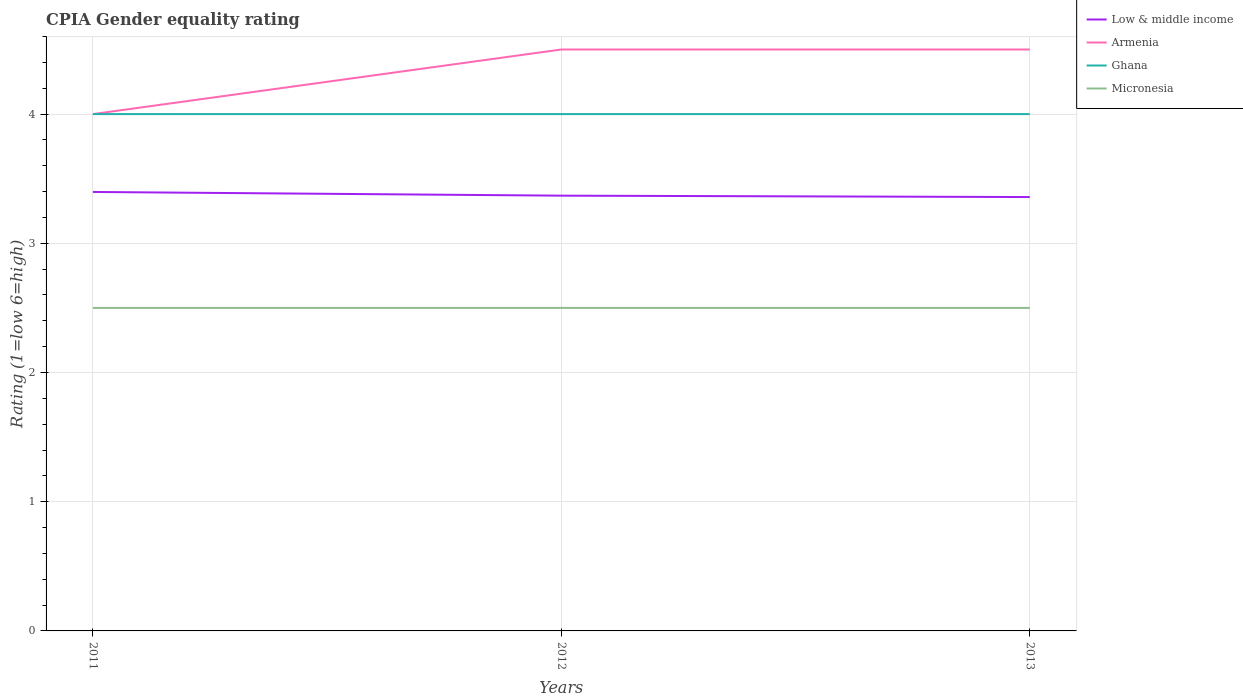How many different coloured lines are there?
Provide a short and direct response. 4. Is the number of lines equal to the number of legend labels?
Your answer should be very brief. Yes. Across all years, what is the maximum CPIA rating in Ghana?
Give a very brief answer. 4. In which year was the CPIA rating in Armenia maximum?
Your answer should be very brief. 2011. Is the CPIA rating in Micronesia strictly greater than the CPIA rating in Armenia over the years?
Provide a succinct answer. Yes. How many lines are there?
Ensure brevity in your answer.  4. How many years are there in the graph?
Provide a short and direct response. 3. Does the graph contain any zero values?
Your answer should be compact. No. Where does the legend appear in the graph?
Offer a terse response. Top right. How are the legend labels stacked?
Your answer should be very brief. Vertical. What is the title of the graph?
Keep it short and to the point. CPIA Gender equality rating. What is the Rating (1=low 6=high) of Low & middle income in 2011?
Provide a short and direct response. 3.4. What is the Rating (1=low 6=high) in Armenia in 2011?
Give a very brief answer. 4. What is the Rating (1=low 6=high) in Ghana in 2011?
Offer a terse response. 4. What is the Rating (1=low 6=high) in Low & middle income in 2012?
Offer a terse response. 3.37. What is the Rating (1=low 6=high) of Armenia in 2012?
Keep it short and to the point. 4.5. What is the Rating (1=low 6=high) of Low & middle income in 2013?
Keep it short and to the point. 3.36. What is the Rating (1=low 6=high) in Armenia in 2013?
Give a very brief answer. 4.5. What is the Rating (1=low 6=high) of Ghana in 2013?
Provide a succinct answer. 4. What is the Rating (1=low 6=high) of Micronesia in 2013?
Make the answer very short. 2.5. Across all years, what is the maximum Rating (1=low 6=high) of Low & middle income?
Make the answer very short. 3.4. Across all years, what is the minimum Rating (1=low 6=high) in Low & middle income?
Give a very brief answer. 3.36. Across all years, what is the minimum Rating (1=low 6=high) in Ghana?
Make the answer very short. 4. Across all years, what is the minimum Rating (1=low 6=high) of Micronesia?
Offer a terse response. 2.5. What is the total Rating (1=low 6=high) of Low & middle income in the graph?
Keep it short and to the point. 10.12. What is the total Rating (1=low 6=high) in Armenia in the graph?
Provide a succinct answer. 13. What is the difference between the Rating (1=low 6=high) of Low & middle income in 2011 and that in 2012?
Offer a very short reply. 0.03. What is the difference between the Rating (1=low 6=high) in Micronesia in 2011 and that in 2012?
Your answer should be compact. 0. What is the difference between the Rating (1=low 6=high) of Low & middle income in 2011 and that in 2013?
Your answer should be compact. 0.04. What is the difference between the Rating (1=low 6=high) of Ghana in 2011 and that in 2013?
Your answer should be compact. 0. What is the difference between the Rating (1=low 6=high) in Low & middle income in 2012 and that in 2013?
Offer a very short reply. 0.01. What is the difference between the Rating (1=low 6=high) of Armenia in 2012 and that in 2013?
Your answer should be very brief. 0. What is the difference between the Rating (1=low 6=high) of Ghana in 2012 and that in 2013?
Keep it short and to the point. 0. What is the difference between the Rating (1=low 6=high) of Low & middle income in 2011 and the Rating (1=low 6=high) of Armenia in 2012?
Give a very brief answer. -1.1. What is the difference between the Rating (1=low 6=high) in Low & middle income in 2011 and the Rating (1=low 6=high) in Ghana in 2012?
Ensure brevity in your answer.  -0.6. What is the difference between the Rating (1=low 6=high) of Low & middle income in 2011 and the Rating (1=low 6=high) of Micronesia in 2012?
Your answer should be very brief. 0.9. What is the difference between the Rating (1=low 6=high) in Armenia in 2011 and the Rating (1=low 6=high) in Ghana in 2012?
Provide a succinct answer. 0. What is the difference between the Rating (1=low 6=high) in Armenia in 2011 and the Rating (1=low 6=high) in Micronesia in 2012?
Ensure brevity in your answer.  1.5. What is the difference between the Rating (1=low 6=high) of Ghana in 2011 and the Rating (1=low 6=high) of Micronesia in 2012?
Keep it short and to the point. 1.5. What is the difference between the Rating (1=low 6=high) in Low & middle income in 2011 and the Rating (1=low 6=high) in Armenia in 2013?
Give a very brief answer. -1.1. What is the difference between the Rating (1=low 6=high) of Low & middle income in 2011 and the Rating (1=low 6=high) of Ghana in 2013?
Provide a short and direct response. -0.6. What is the difference between the Rating (1=low 6=high) in Low & middle income in 2011 and the Rating (1=low 6=high) in Micronesia in 2013?
Offer a very short reply. 0.9. What is the difference between the Rating (1=low 6=high) in Ghana in 2011 and the Rating (1=low 6=high) in Micronesia in 2013?
Ensure brevity in your answer.  1.5. What is the difference between the Rating (1=low 6=high) in Low & middle income in 2012 and the Rating (1=low 6=high) in Armenia in 2013?
Your answer should be very brief. -1.13. What is the difference between the Rating (1=low 6=high) in Low & middle income in 2012 and the Rating (1=low 6=high) in Ghana in 2013?
Provide a succinct answer. -0.63. What is the difference between the Rating (1=low 6=high) of Low & middle income in 2012 and the Rating (1=low 6=high) of Micronesia in 2013?
Give a very brief answer. 0.87. What is the difference between the Rating (1=low 6=high) in Armenia in 2012 and the Rating (1=low 6=high) in Micronesia in 2013?
Ensure brevity in your answer.  2. What is the average Rating (1=low 6=high) in Low & middle income per year?
Keep it short and to the point. 3.37. What is the average Rating (1=low 6=high) of Armenia per year?
Your answer should be very brief. 4.33. What is the average Rating (1=low 6=high) in Micronesia per year?
Ensure brevity in your answer.  2.5. In the year 2011, what is the difference between the Rating (1=low 6=high) in Low & middle income and Rating (1=low 6=high) in Armenia?
Offer a very short reply. -0.6. In the year 2011, what is the difference between the Rating (1=low 6=high) in Low & middle income and Rating (1=low 6=high) in Ghana?
Your answer should be compact. -0.6. In the year 2011, what is the difference between the Rating (1=low 6=high) of Low & middle income and Rating (1=low 6=high) of Micronesia?
Provide a succinct answer. 0.9. In the year 2011, what is the difference between the Rating (1=low 6=high) of Armenia and Rating (1=low 6=high) of Ghana?
Give a very brief answer. 0. In the year 2012, what is the difference between the Rating (1=low 6=high) in Low & middle income and Rating (1=low 6=high) in Armenia?
Offer a very short reply. -1.13. In the year 2012, what is the difference between the Rating (1=low 6=high) of Low & middle income and Rating (1=low 6=high) of Ghana?
Make the answer very short. -0.63. In the year 2012, what is the difference between the Rating (1=low 6=high) of Low & middle income and Rating (1=low 6=high) of Micronesia?
Offer a very short reply. 0.87. In the year 2012, what is the difference between the Rating (1=low 6=high) in Armenia and Rating (1=low 6=high) in Ghana?
Your answer should be very brief. 0.5. In the year 2013, what is the difference between the Rating (1=low 6=high) in Low & middle income and Rating (1=low 6=high) in Armenia?
Offer a very short reply. -1.14. In the year 2013, what is the difference between the Rating (1=low 6=high) in Low & middle income and Rating (1=low 6=high) in Ghana?
Make the answer very short. -0.64. In the year 2013, what is the difference between the Rating (1=low 6=high) of Low & middle income and Rating (1=low 6=high) of Micronesia?
Offer a very short reply. 0.86. In the year 2013, what is the difference between the Rating (1=low 6=high) in Armenia and Rating (1=low 6=high) in Ghana?
Keep it short and to the point. 0.5. In the year 2013, what is the difference between the Rating (1=low 6=high) in Armenia and Rating (1=low 6=high) in Micronesia?
Ensure brevity in your answer.  2. What is the ratio of the Rating (1=low 6=high) in Low & middle income in 2011 to that in 2012?
Provide a succinct answer. 1.01. What is the ratio of the Rating (1=low 6=high) of Armenia in 2011 to that in 2012?
Ensure brevity in your answer.  0.89. What is the ratio of the Rating (1=low 6=high) in Micronesia in 2011 to that in 2012?
Provide a short and direct response. 1. What is the ratio of the Rating (1=low 6=high) of Low & middle income in 2011 to that in 2013?
Make the answer very short. 1.01. What is the ratio of the Rating (1=low 6=high) in Armenia in 2011 to that in 2013?
Offer a terse response. 0.89. What is the ratio of the Rating (1=low 6=high) of Low & middle income in 2012 to that in 2013?
Offer a very short reply. 1. What is the difference between the highest and the second highest Rating (1=low 6=high) in Low & middle income?
Give a very brief answer. 0.03. What is the difference between the highest and the second highest Rating (1=low 6=high) in Micronesia?
Keep it short and to the point. 0. What is the difference between the highest and the lowest Rating (1=low 6=high) of Low & middle income?
Offer a very short reply. 0.04. What is the difference between the highest and the lowest Rating (1=low 6=high) of Armenia?
Your answer should be compact. 0.5. What is the difference between the highest and the lowest Rating (1=low 6=high) of Micronesia?
Keep it short and to the point. 0. 